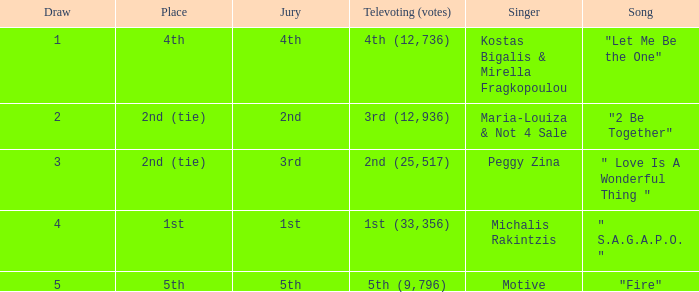Kostas Bigalis & Mirella Fragkopoulou the singer had what has the jury? 4th. Would you be able to parse every entry in this table? {'header': ['Draw', 'Place', 'Jury', 'Televoting (votes)', 'Singer', 'Song'], 'rows': [['1', '4th', '4th', '4th (12,736)', 'Kostas Bigalis & Mirella Fragkopoulou', '"Let Me Be the One"'], ['2', '2nd (tie)', '2nd', '3rd (12,936)', 'Maria-Louiza & Not 4 Sale', '"2 Be Together"'], ['3', '2nd (tie)', '3rd', '2nd (25,517)', 'Peggy Zina', '" Love Is A Wonderful Thing "'], ['4', '1st', '1st', '1st (33,356)', 'Michalis Rakintzis', '" S.A.G.A.P.O. "'], ['5', '5th', '5th', '5th (9,796)', 'Motive', '"Fire"']]} 